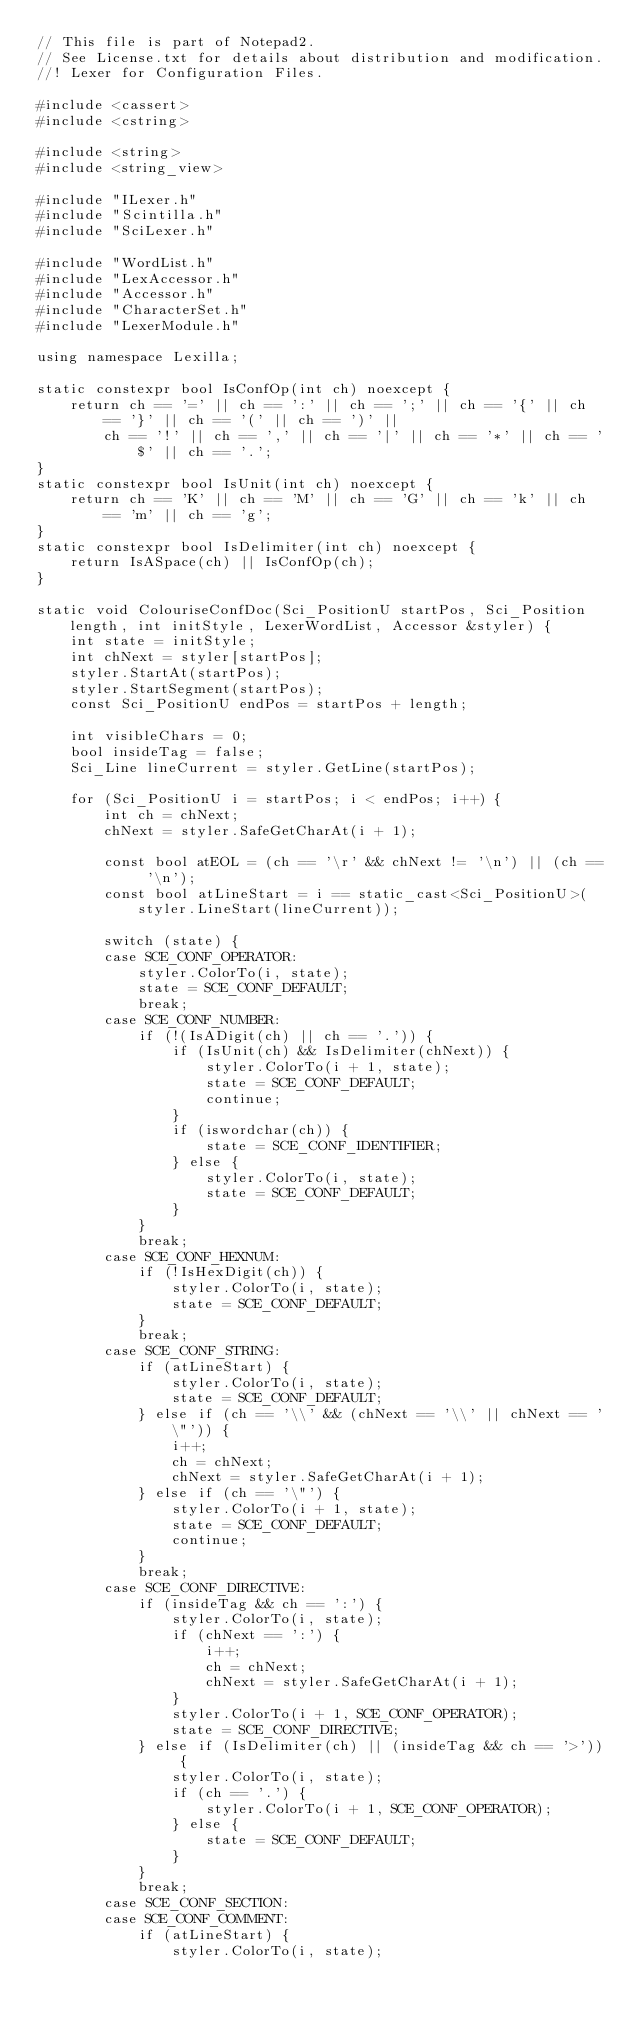<code> <loc_0><loc_0><loc_500><loc_500><_C++_>// This file is part of Notepad2.
// See License.txt for details about distribution and modification.
//! Lexer for Configuration Files.

#include <cassert>
#include <cstring>

#include <string>
#include <string_view>

#include "ILexer.h"
#include "Scintilla.h"
#include "SciLexer.h"

#include "WordList.h"
#include "LexAccessor.h"
#include "Accessor.h"
#include "CharacterSet.h"
#include "LexerModule.h"

using namespace Lexilla;

static constexpr bool IsConfOp(int ch) noexcept {
	return ch == '=' || ch == ':' || ch == ';' || ch == '{' || ch == '}' || ch == '(' || ch == ')' ||
		ch == '!' || ch == ',' || ch == '|' || ch == '*' || ch == '$' || ch == '.';
}
static constexpr bool IsUnit(int ch) noexcept {
	return ch == 'K' || ch == 'M' || ch == 'G' || ch == 'k' || ch == 'm' || ch == 'g';
}
static constexpr bool IsDelimiter(int ch) noexcept {
	return IsASpace(ch) || IsConfOp(ch);
}

static void ColouriseConfDoc(Sci_PositionU startPos, Sci_Position length, int initStyle, LexerWordList, Accessor &styler) {
	int state = initStyle;
	int chNext = styler[startPos];
	styler.StartAt(startPos);
	styler.StartSegment(startPos);
	const Sci_PositionU endPos = startPos + length;

	int visibleChars = 0;
	bool insideTag = false;
	Sci_Line lineCurrent = styler.GetLine(startPos);

	for (Sci_PositionU i = startPos; i < endPos; i++) {
		int ch = chNext;
		chNext = styler.SafeGetCharAt(i + 1);

		const bool atEOL = (ch == '\r' && chNext != '\n') || (ch == '\n');
		const bool atLineStart = i == static_cast<Sci_PositionU>(styler.LineStart(lineCurrent));

		switch (state) {
		case SCE_CONF_OPERATOR:
			styler.ColorTo(i, state);
			state = SCE_CONF_DEFAULT;
			break;
		case SCE_CONF_NUMBER:
			if (!(IsADigit(ch) || ch == '.')) {
				if (IsUnit(ch) && IsDelimiter(chNext)) {
					styler.ColorTo(i + 1, state);
					state = SCE_CONF_DEFAULT;
					continue;
				}
				if (iswordchar(ch)) {
					state = SCE_CONF_IDENTIFIER;
				} else {
					styler.ColorTo(i, state);
					state = SCE_CONF_DEFAULT;
				}
			}
			break;
		case SCE_CONF_HEXNUM:
			if (!IsHexDigit(ch)) {
				styler.ColorTo(i, state);
				state = SCE_CONF_DEFAULT;
			}
			break;
		case SCE_CONF_STRING:
			if (atLineStart) {
				styler.ColorTo(i, state);
				state = SCE_CONF_DEFAULT;
			} else if (ch == '\\' && (chNext == '\\' || chNext == '\"')) {
				i++;
				ch = chNext;
				chNext = styler.SafeGetCharAt(i + 1);
			} else if (ch == '\"') {
				styler.ColorTo(i + 1, state);
				state = SCE_CONF_DEFAULT;
				continue;
			}
			break;
		case SCE_CONF_DIRECTIVE:
			if (insideTag && ch == ':') {
				styler.ColorTo(i, state);
				if (chNext == ':') {
					i++;
					ch = chNext;
					chNext = styler.SafeGetCharAt(i + 1);
				}
				styler.ColorTo(i + 1, SCE_CONF_OPERATOR);
				state = SCE_CONF_DIRECTIVE;
			} else if (IsDelimiter(ch) || (insideTag && ch == '>')) {
				styler.ColorTo(i, state);
				if (ch == '.') {
					styler.ColorTo(i + 1, SCE_CONF_OPERATOR);
				} else {
					state = SCE_CONF_DEFAULT;
				}
			}
			break;
		case SCE_CONF_SECTION:
		case SCE_CONF_COMMENT:
			if (atLineStart) {
				styler.ColorTo(i, state);</code> 